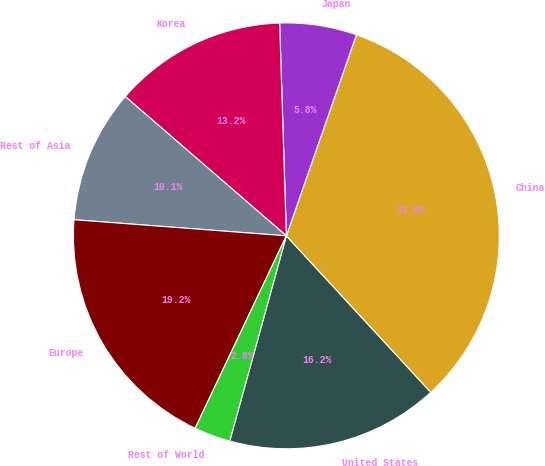<chart> <loc_0><loc_0><loc_500><loc_500><pie_chart><fcel>United States<fcel>China<fcel>Japan<fcel>Korea<fcel>Rest of Asia<fcel>Europe<fcel>Rest of World<nl><fcel>16.15%<fcel>32.8%<fcel>5.84%<fcel>13.15%<fcel>10.14%<fcel>19.16%<fcel>2.76%<nl></chart> 